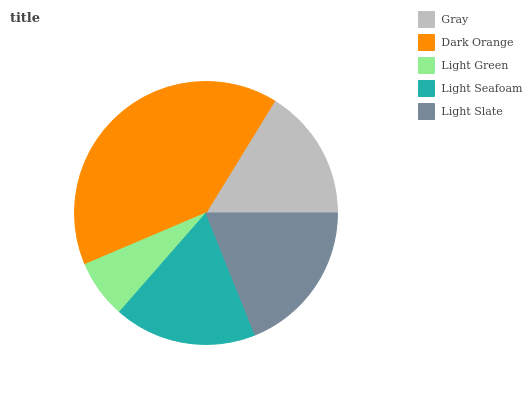Is Light Green the minimum?
Answer yes or no. Yes. Is Dark Orange the maximum?
Answer yes or no. Yes. Is Dark Orange the minimum?
Answer yes or no. No. Is Light Green the maximum?
Answer yes or no. No. Is Dark Orange greater than Light Green?
Answer yes or no. Yes. Is Light Green less than Dark Orange?
Answer yes or no. Yes. Is Light Green greater than Dark Orange?
Answer yes or no. No. Is Dark Orange less than Light Green?
Answer yes or no. No. Is Light Seafoam the high median?
Answer yes or no. Yes. Is Light Seafoam the low median?
Answer yes or no. Yes. Is Gray the high median?
Answer yes or no. No. Is Light Green the low median?
Answer yes or no. No. 